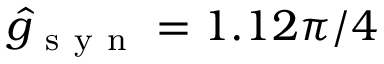<formula> <loc_0><loc_0><loc_500><loc_500>\hat { g } _ { s y n } = 1 . 1 2 \pi / 4</formula> 